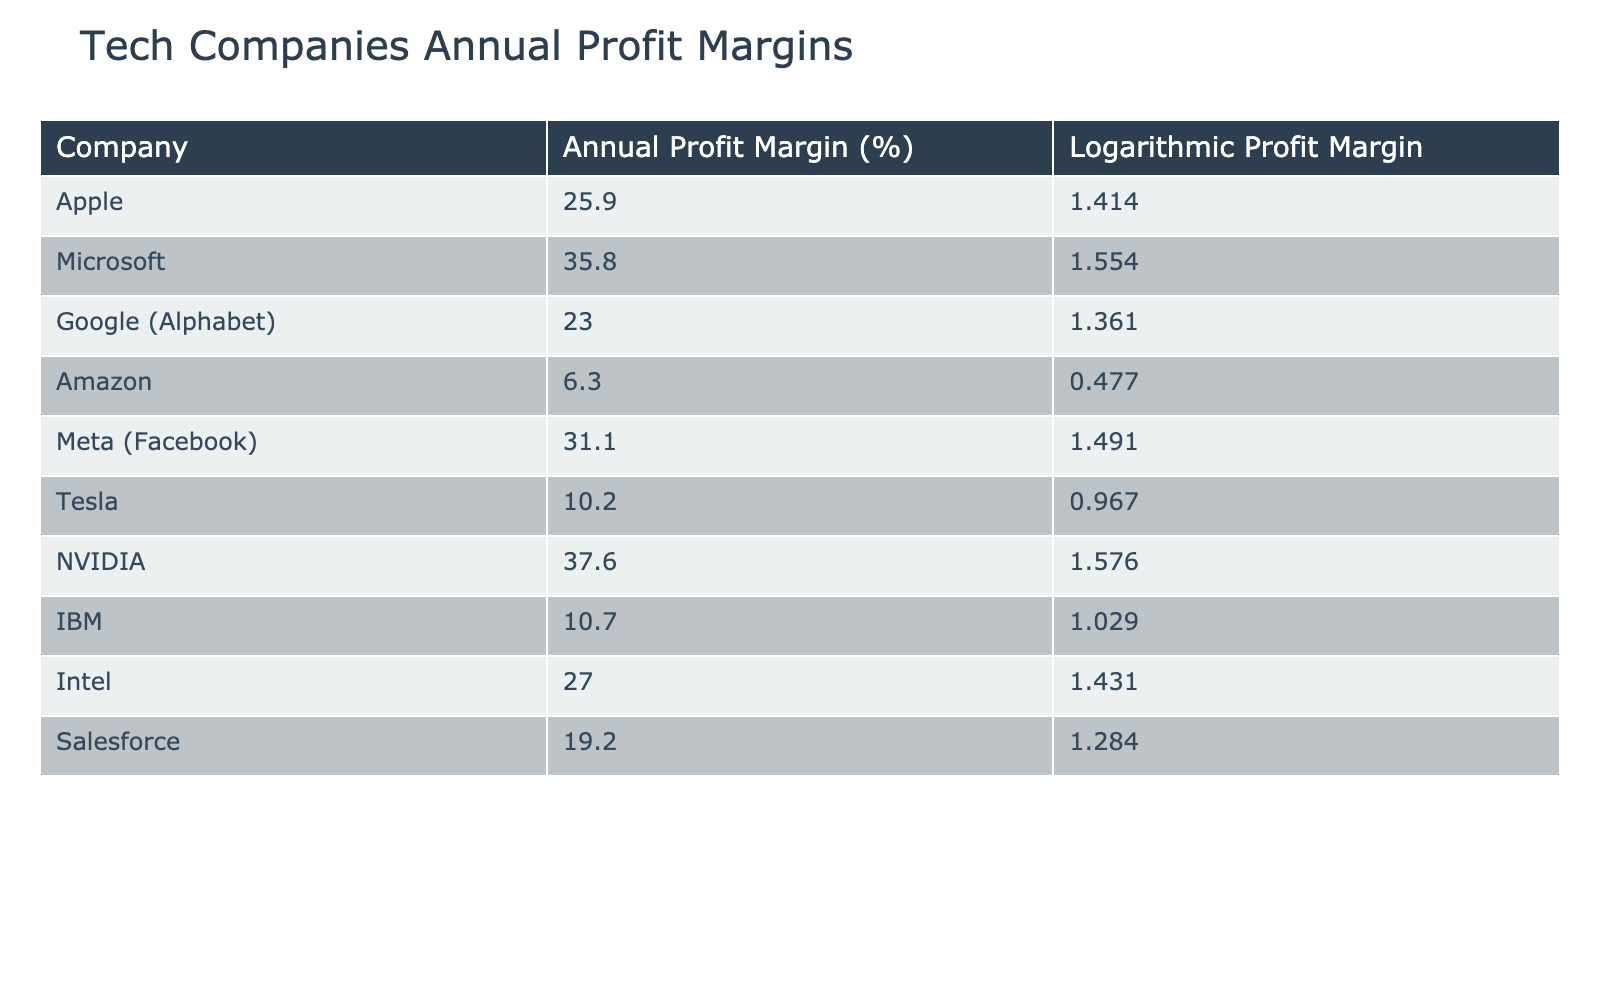What's the company with the highest annual profit margin? By examining the "Annual Profit Margin (%)" column, we see that Microsoft's 35.8% is greater than any other listed company.
Answer: Microsoft What is the annual profit margin of Apple? The table provides the annual profit margin for Apple, which is listed as 25.9%.
Answer: 25.9% Is Amazon's profit margin higher than Tesla's? Comparing the annual profit margins from the table, Amazon has 6.3% and Tesla has 10.2%. Since 10.2% is greater than 6.3%, the answer is no.
Answer: No What is the average annual profit margin of the companies listed? To calculate the average, add up all the profit margins: 25.9 + 35.8 + 23.0 + 6.3 + 31.1 + 10.2 + 37.6 + 10.7 + 27.0 + 19.2 =  225.8. There are 10 companies, so dividing gives 225.8 / 10 = 22.58%.
Answer: 22.58% Which company has an annual profit margin closest to 20%? Reviewing the annual profit margins, Salesforce is the closest with 19.2%, as no other company is nearer to 20%.
Answer: Salesforce Is the logarithmic profit margin of NVIDIA greater than that of IBM? The logarithmic values show 1.576 for NVIDIA and 1.029 for IBM. Since 1.576 is higher than 1.029, the answer is yes.
Answer: Yes What is the difference between the annual profit margin of Microsoft and Google (Alphabet)? The difference is calculated by subtracting Google’s profit margin (23.0%) from Microsoft’s (35.8%), which is 35.8 - 23.0 = 12.8%.
Answer: 12.8% Which company has the lowest logarithmic profit margin? In the "Logarithmic Profit Margin" column, the lowest value is 0.477 for Amazon, so that is the answer.
Answer: Amazon If we combine the profit margins of Apple, Meta, and Intel, what is the total? Adding the profit margins: 25.9 + 31.1 + 27.0 = 84%. Thus, the total profit margin of these companies is 84%.
Answer: 84% 